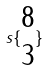<formula> <loc_0><loc_0><loc_500><loc_500>s \{ \begin{matrix} 8 \\ 3 \end{matrix} \}</formula> 